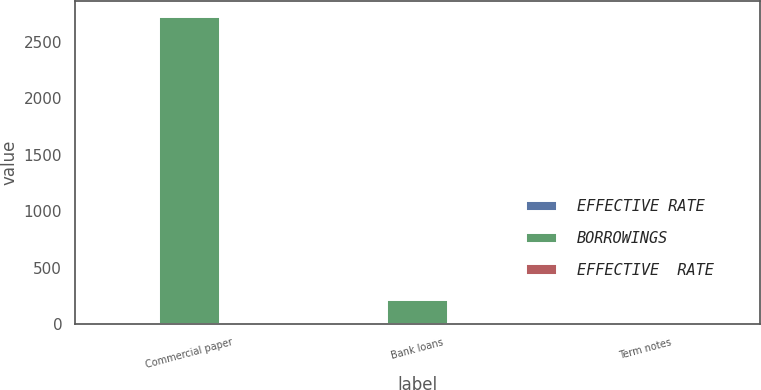<chart> <loc_0><loc_0><loc_500><loc_500><stacked_bar_chart><ecel><fcel>Commercial paper<fcel>Bank loans<fcel>Term notes<nl><fcel>EFFECTIVE RATE<fcel>1.3<fcel>6.9<fcel>1.7<nl><fcel>BORROWINGS<fcel>2723.7<fcel>210.2<fcel>3.6<nl><fcel>EFFECTIVE  RATE<fcel>0.7<fcel>5.5<fcel>1.5<nl></chart> 